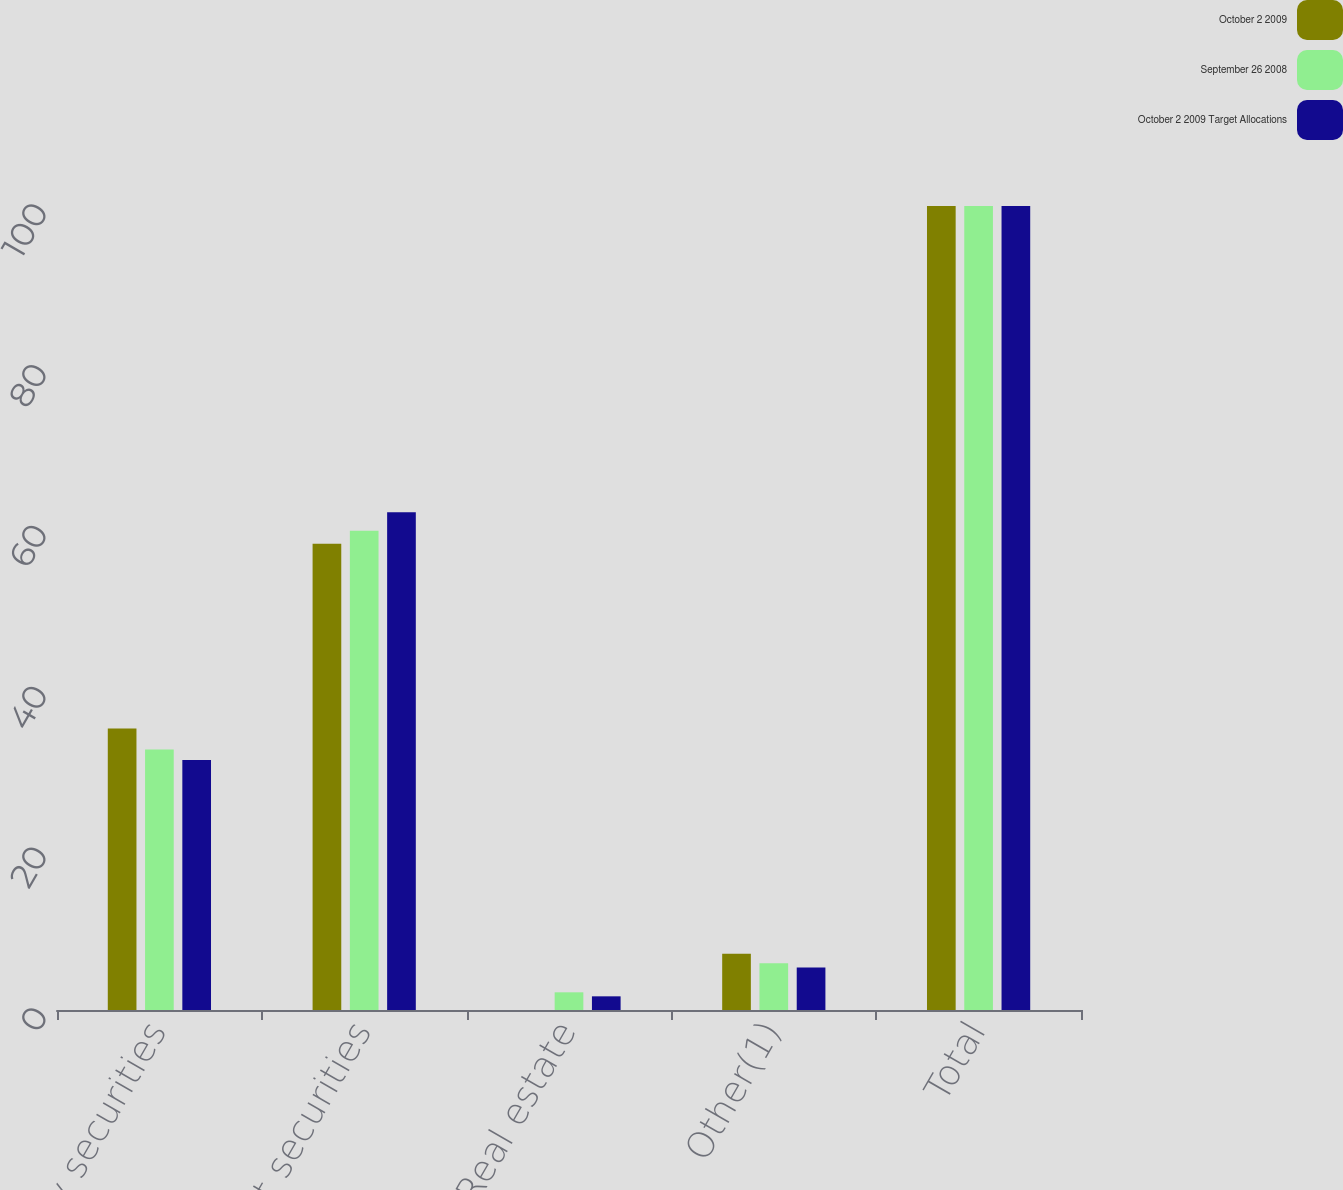Convert chart to OTSL. <chart><loc_0><loc_0><loc_500><loc_500><stacked_bar_chart><ecel><fcel>Equity securities<fcel>Debt securities<fcel>Real estate<fcel>Other(1)<fcel>Total<nl><fcel>October 2 2009<fcel>35<fcel>58<fcel>0<fcel>7<fcel>100<nl><fcel>September 26 2008<fcel>32.4<fcel>59.6<fcel>2.2<fcel>5.8<fcel>100<nl><fcel>October 2 2009 Target Allocations<fcel>31.1<fcel>61.9<fcel>1.7<fcel>5.3<fcel>100<nl></chart> 